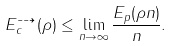<formula> <loc_0><loc_0><loc_500><loc_500>E _ { c } ^ { \dashrightarrow } ( \rho ) \leq \lim _ { n \to \infty } \frac { E _ { p } ( \rho n ) } { n } .</formula> 